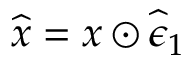Convert formula to latex. <formula><loc_0><loc_0><loc_500><loc_500>\widehat { x } = x \odot \widehat { \epsilon } _ { 1 }</formula> 